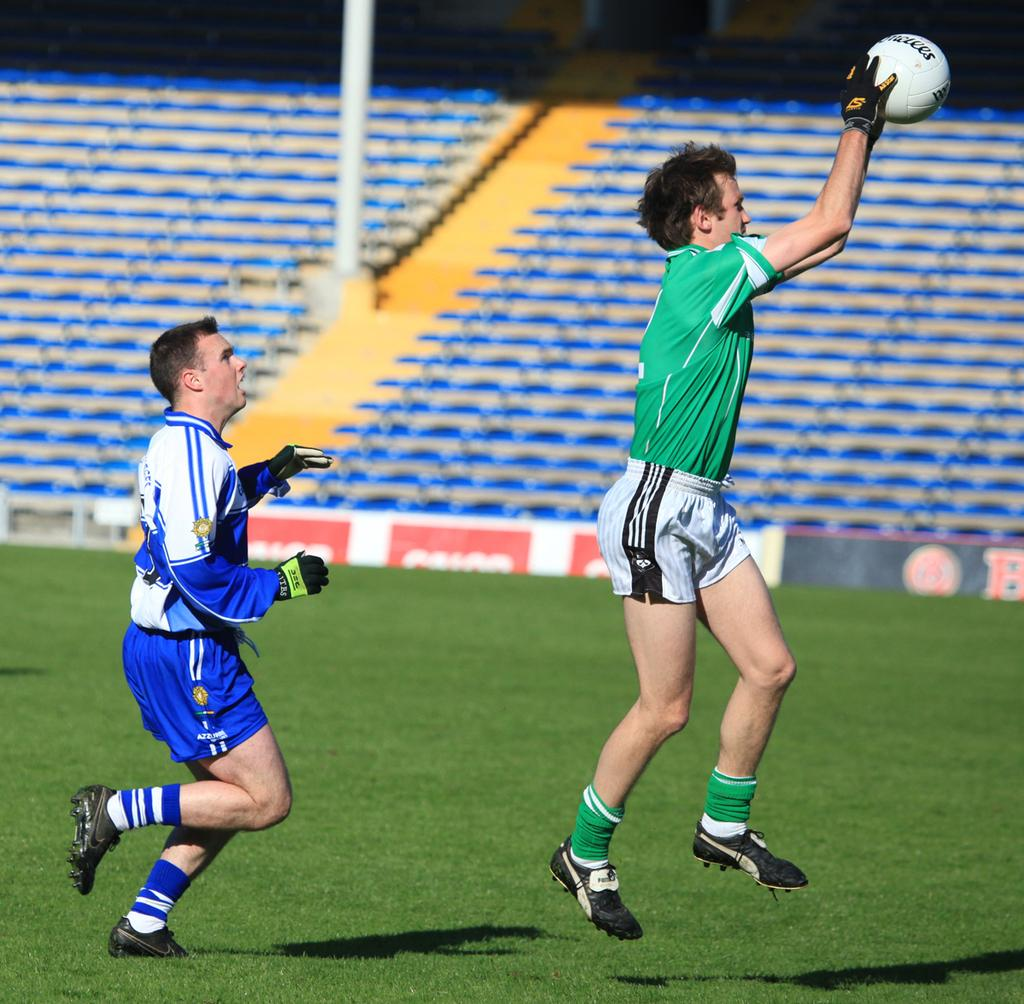How many people are in the image? There are two men in the image. What are the men doing in the image? The men are playing a game. What can be seen in the background of the image? There are chairs and a pole in the background of the image. Where are the children playing in the image? There are no children present in the image. What type of mine is visible in the image? There is no mine present in the image. 